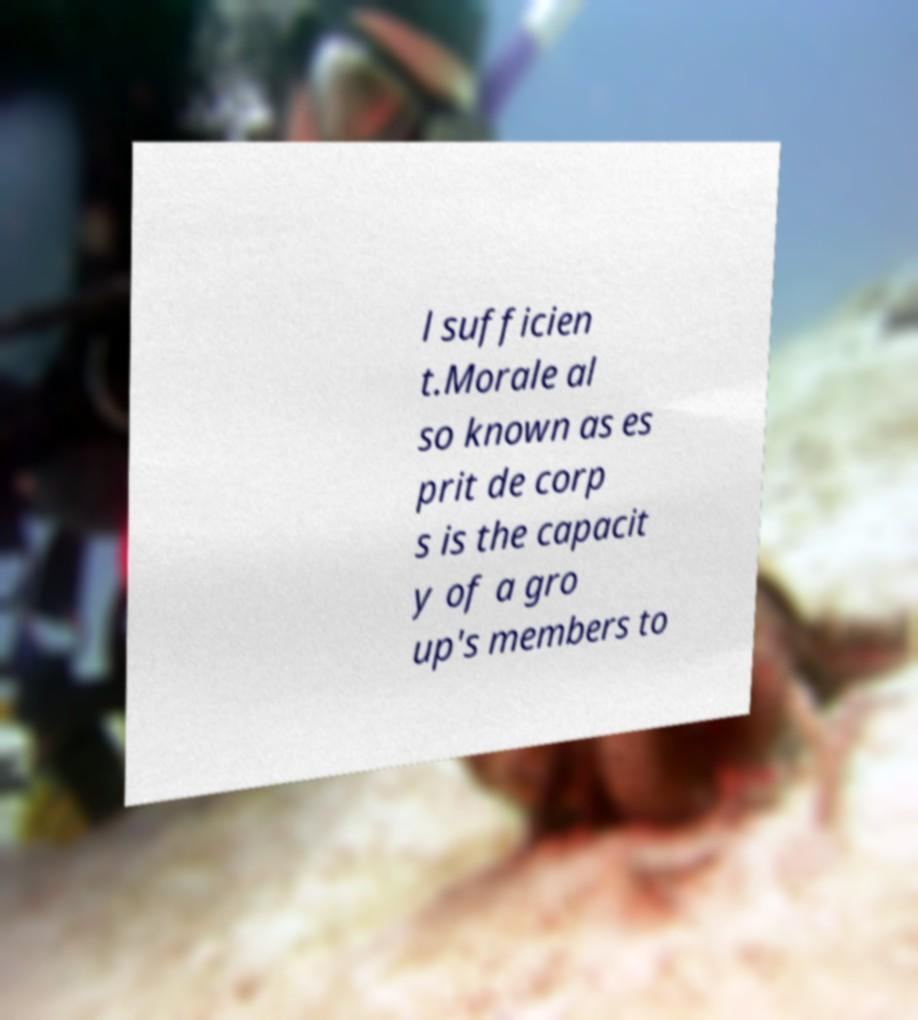Can you accurately transcribe the text from the provided image for me? l sufficien t.Morale al so known as es prit de corp s is the capacit y of a gro up's members to 